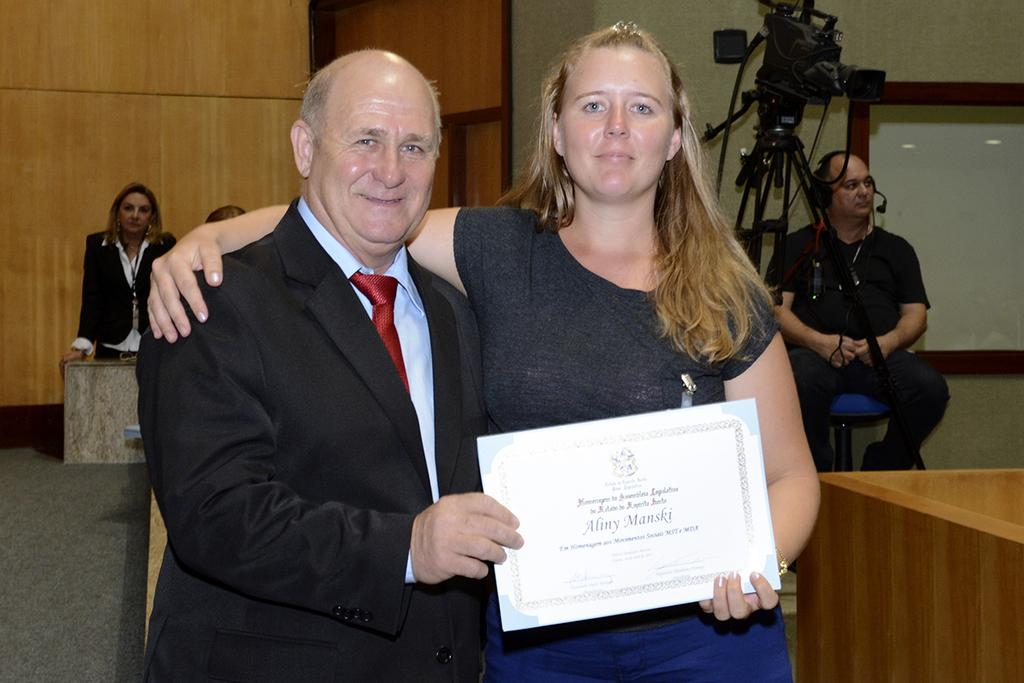What is the woman in the image holding? The woman is holding a certificate in the image. What is the woman wearing in the image? The woman is wearing a t-shirt and trousers in the image. Can you describe the man in the image? The man is wearing a tie, shirt, and coat in the image. What might the woman have achieved, based on the presence of the certificate? The woman might have achieved a milestone or received recognition, as indicated by the certificate. What type of wound can be seen on the woman's arm in the image? There is no wound visible on the woman's arm in the image. What kind of beast is present in the image? There is no beast present in the image. 